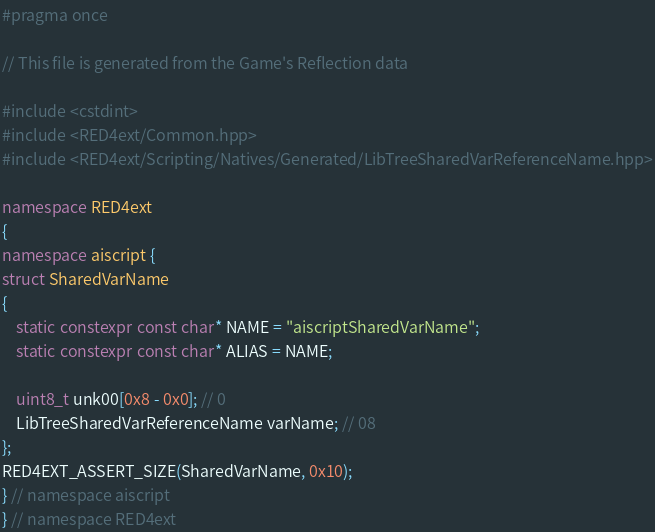Convert code to text. <code><loc_0><loc_0><loc_500><loc_500><_C++_>#pragma once

// This file is generated from the Game's Reflection data

#include <cstdint>
#include <RED4ext/Common.hpp>
#include <RED4ext/Scripting/Natives/Generated/LibTreeSharedVarReferenceName.hpp>

namespace RED4ext
{
namespace aiscript { 
struct SharedVarName
{
    static constexpr const char* NAME = "aiscriptSharedVarName";
    static constexpr const char* ALIAS = NAME;

    uint8_t unk00[0x8 - 0x0]; // 0
    LibTreeSharedVarReferenceName varName; // 08
};
RED4EXT_ASSERT_SIZE(SharedVarName, 0x10);
} // namespace aiscript
} // namespace RED4ext
</code> 